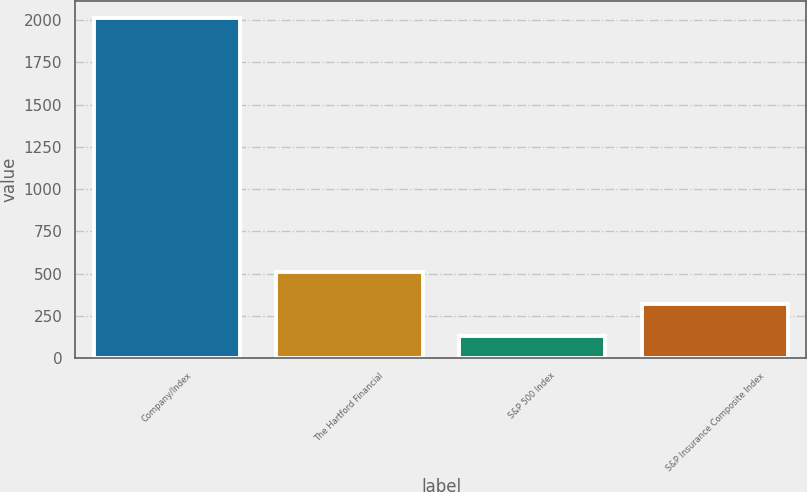<chart> <loc_0><loc_0><loc_500><loc_500><bar_chart><fcel>Company/Index<fcel>The Hartford Financial<fcel>S&P 500 Index<fcel>S&P Insurance Composite Index<nl><fcel>2013<fcel>508.51<fcel>132.39<fcel>320.45<nl></chart> 